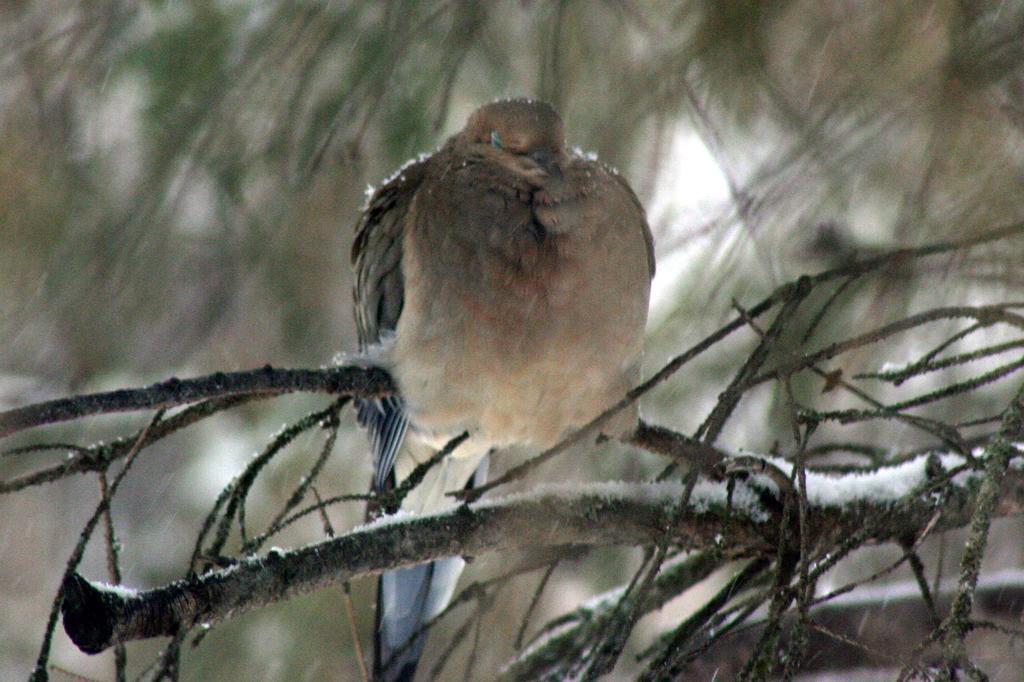Could you give a brief overview of what you see in this image? Background portion of the picture is blurry. In this picture we can see a bird and branches. 